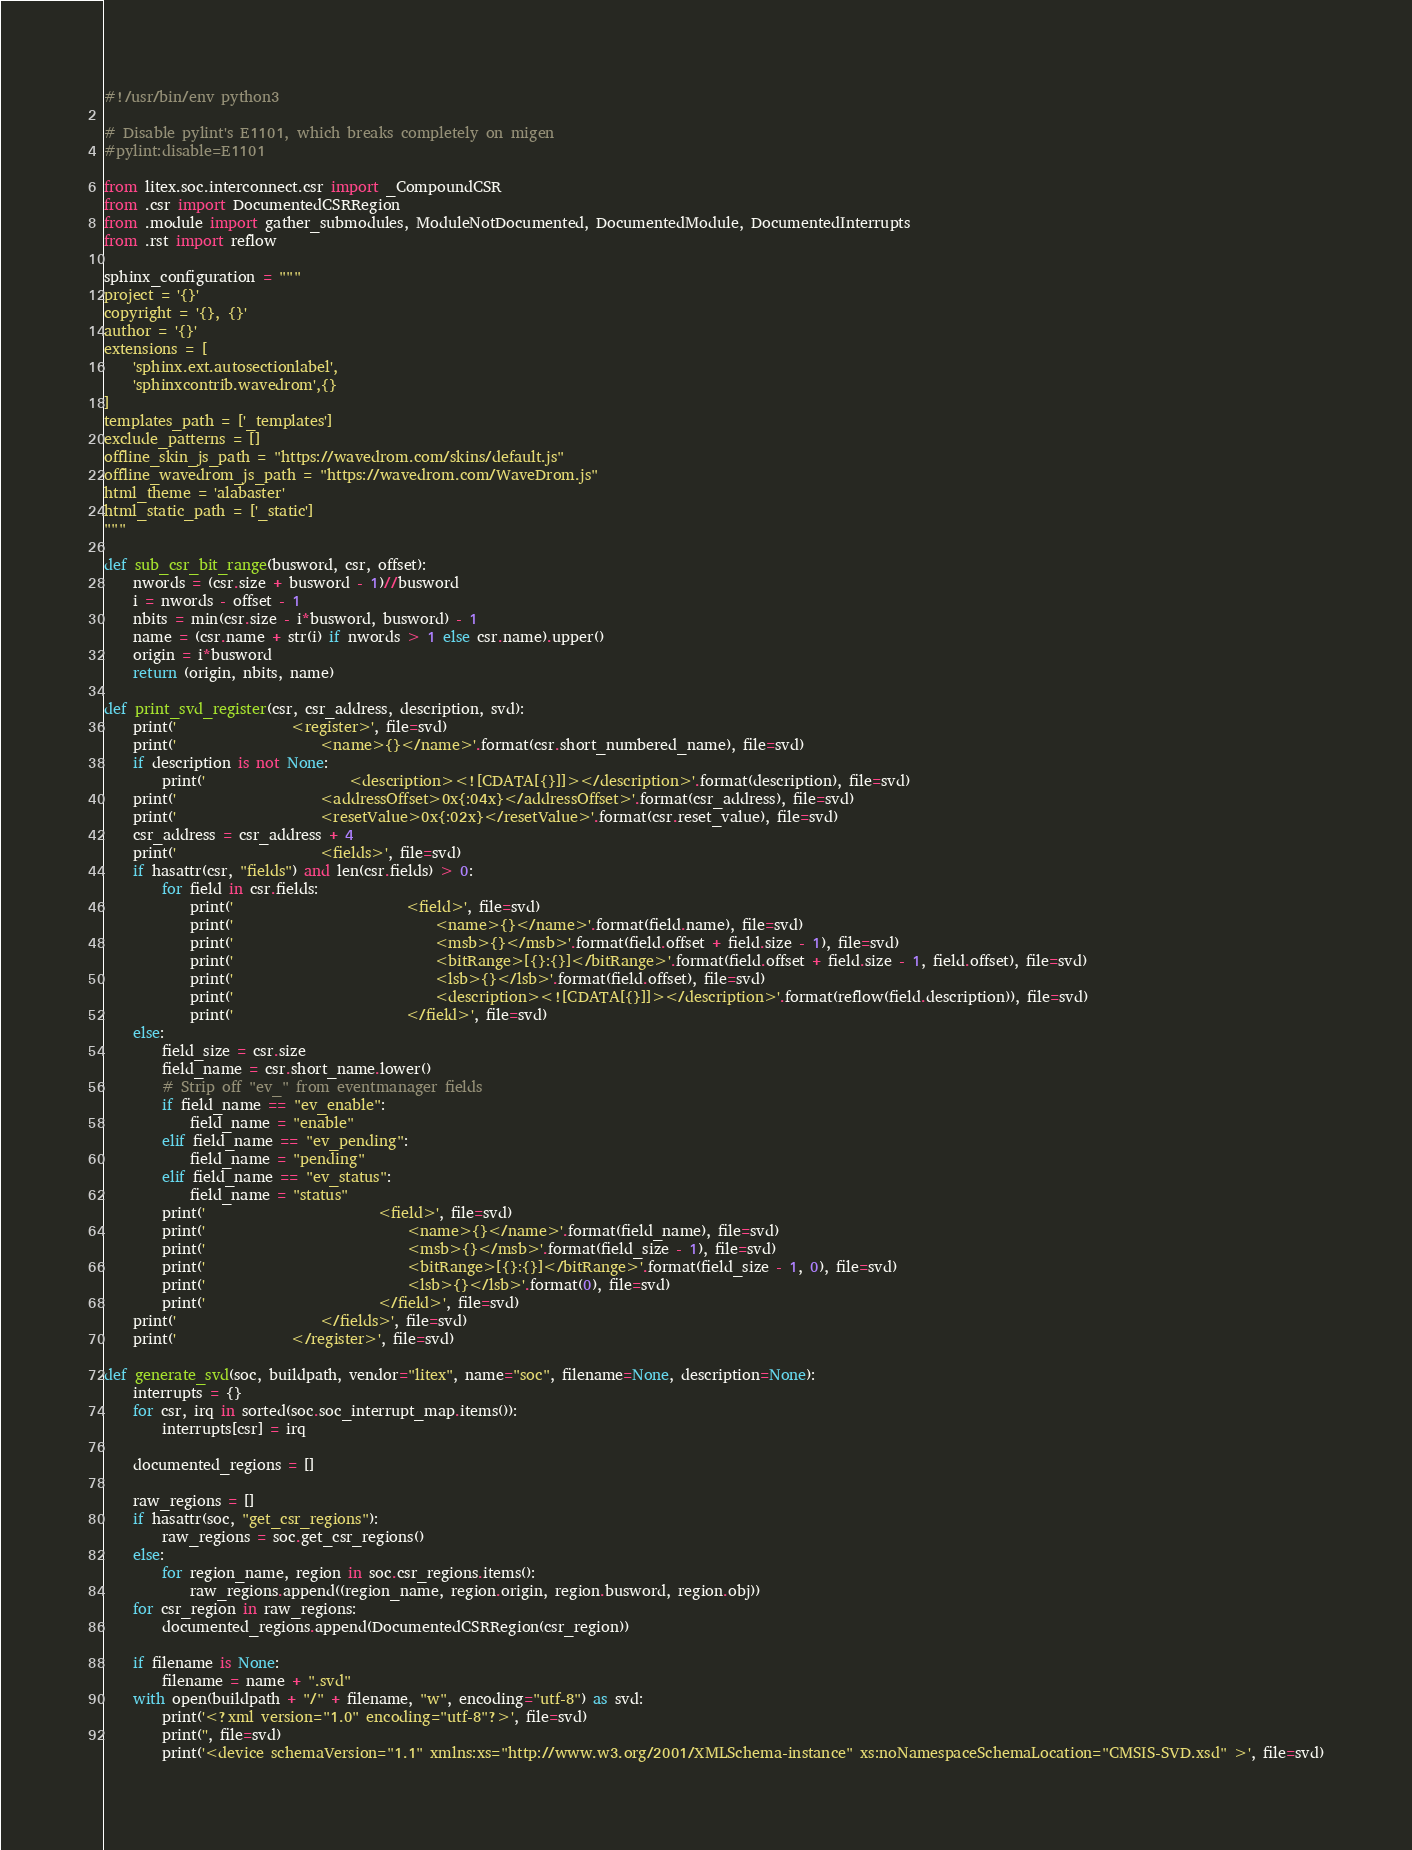<code> <loc_0><loc_0><loc_500><loc_500><_Python_>#!/usr/bin/env python3

# Disable pylint's E1101, which breaks completely on migen
#pylint:disable=E1101

from litex.soc.interconnect.csr import _CompoundCSR
from .csr import DocumentedCSRRegion
from .module import gather_submodules, ModuleNotDocumented, DocumentedModule, DocumentedInterrupts
from .rst import reflow

sphinx_configuration = """
project = '{}'
copyright = '{}, {}'
author = '{}'
extensions = [
    'sphinx.ext.autosectionlabel',
    'sphinxcontrib.wavedrom',{}
]
templates_path = ['_templates']
exclude_patterns = []
offline_skin_js_path = "https://wavedrom.com/skins/default.js"
offline_wavedrom_js_path = "https://wavedrom.com/WaveDrom.js"
html_theme = 'alabaster'
html_static_path = ['_static']
"""

def sub_csr_bit_range(busword, csr, offset):
    nwords = (csr.size + busword - 1)//busword
    i = nwords - offset - 1
    nbits = min(csr.size - i*busword, busword) - 1
    name = (csr.name + str(i) if nwords > 1 else csr.name).upper()
    origin = i*busword
    return (origin, nbits, name)

def print_svd_register(csr, csr_address, description, svd):
    print('                <register>', file=svd)
    print('                    <name>{}</name>'.format(csr.short_numbered_name), file=svd)
    if description is not None:
        print('                    <description><![CDATA[{}]]></description>'.format(description), file=svd)
    print('                    <addressOffset>0x{:04x}</addressOffset>'.format(csr_address), file=svd)
    print('                    <resetValue>0x{:02x}</resetValue>'.format(csr.reset_value), file=svd)
    csr_address = csr_address + 4
    print('                    <fields>', file=svd)
    if hasattr(csr, "fields") and len(csr.fields) > 0:
        for field in csr.fields:
            print('                        <field>', file=svd)
            print('                            <name>{}</name>'.format(field.name), file=svd)
            print('                            <msb>{}</msb>'.format(field.offset + field.size - 1), file=svd)
            print('                            <bitRange>[{}:{}]</bitRange>'.format(field.offset + field.size - 1, field.offset), file=svd)
            print('                            <lsb>{}</lsb>'.format(field.offset), file=svd)
            print('                            <description><![CDATA[{}]]></description>'.format(reflow(field.description)), file=svd)
            print('                        </field>', file=svd)
    else:
        field_size = csr.size
        field_name = csr.short_name.lower()
        # Strip off "ev_" from eventmanager fields
        if field_name == "ev_enable":
            field_name = "enable"
        elif field_name == "ev_pending":
            field_name = "pending"
        elif field_name == "ev_status":
            field_name = "status"
        print('                        <field>', file=svd)
        print('                            <name>{}</name>'.format(field_name), file=svd)
        print('                            <msb>{}</msb>'.format(field_size - 1), file=svd)
        print('                            <bitRange>[{}:{}]</bitRange>'.format(field_size - 1, 0), file=svd)
        print('                            <lsb>{}</lsb>'.format(0), file=svd)
        print('                        </field>', file=svd)
    print('                    </fields>', file=svd)
    print('                </register>', file=svd)

def generate_svd(soc, buildpath, vendor="litex", name="soc", filename=None, description=None):
    interrupts = {}
    for csr, irq in sorted(soc.soc_interrupt_map.items()):
        interrupts[csr] = irq

    documented_regions = []

    raw_regions = []
    if hasattr(soc, "get_csr_regions"):
        raw_regions = soc.get_csr_regions()
    else:
        for region_name, region in soc.csr_regions.items():
            raw_regions.append((region_name, region.origin, region.busword, region.obj))
    for csr_region in raw_regions:
        documented_regions.append(DocumentedCSRRegion(csr_region))

    if filename is None:
        filename = name + ".svd"
    with open(buildpath + "/" + filename, "w", encoding="utf-8") as svd:
        print('<?xml version="1.0" encoding="utf-8"?>', file=svd)
        print('', file=svd)
        print('<device schemaVersion="1.1" xmlns:xs="http://www.w3.org/2001/XMLSchema-instance" xs:noNamespaceSchemaLocation="CMSIS-SVD.xsd" >', file=svd)</code> 